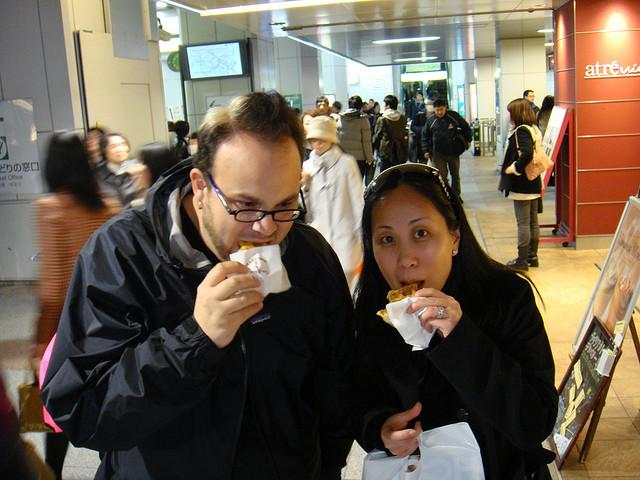Why did this couple take a break? to eat 